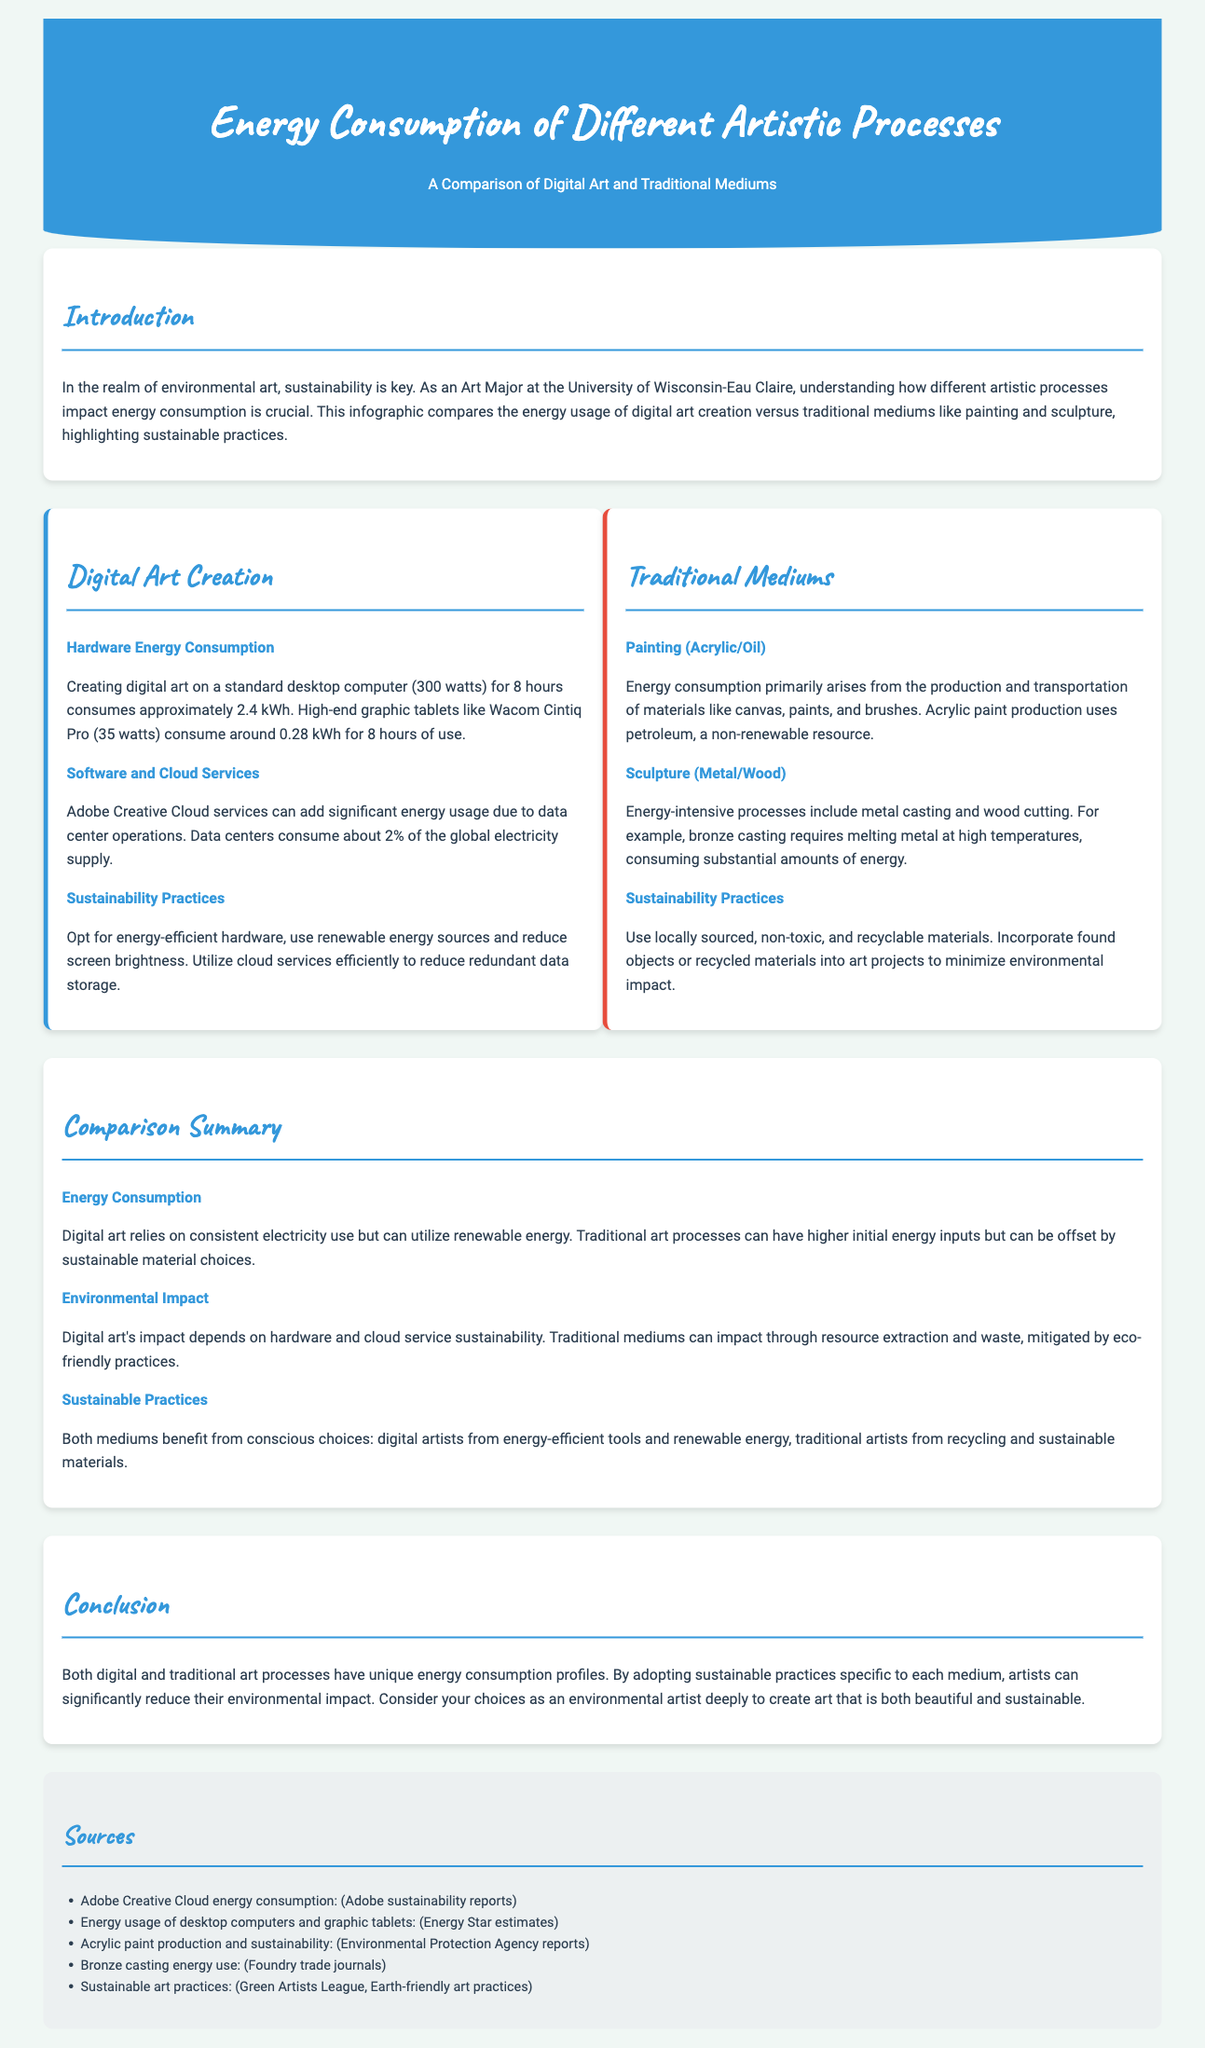What is the power consumption of a standard desktop computer for 8 hours? The power consumption of a standard desktop computer (300 watts) for 8 hours is approximately 2.4 kWh.
Answer: 2.4 kWh What is the energy consumption of a high-end graphic tablet for 8 hours? A high-end graphic tablet like the Wacom Cintiq Pro (35 watts) consumes around 0.28 kWh for 8 hours of use.
Answer: 0.28 kWh What percentage of the global electricity supply is consumed by data centers? Data centers consume about 2% of the global electricity supply.
Answer: 2% What are two sustainable practices for digital art? Sustainable practices include opting for energy-efficient hardware and using renewable energy sources.
Answer: energy-efficient hardware, renewable energy What is a significant environmental impact of traditional painting mediums? Energy consumption primarily arises from the production and transportation of materials like canvas, paints, and brushes.
Answer: production and transportation of materials Which traditional art process requires melting metal at high temperatures? Bronze casting requires melting metal at high temperatures, consuming substantial amounts of energy.
Answer: Bronze casting How can traditional artists minimize environmental impact? Traditional artists can incorporate found objects or recycled materials into art projects to minimize environmental impact.
Answer: found objects or recycled materials What is the main energy reliance factor for digital art? Digital art relies on consistent electricity use but can utilize renewable energy.
Answer: consistent electricity use What is a common sustainability practice mentioned for both digital and traditional art? Both mediums benefit from conscious choices about materials and energy use.
Answer: conscious choices about materials and energy use 